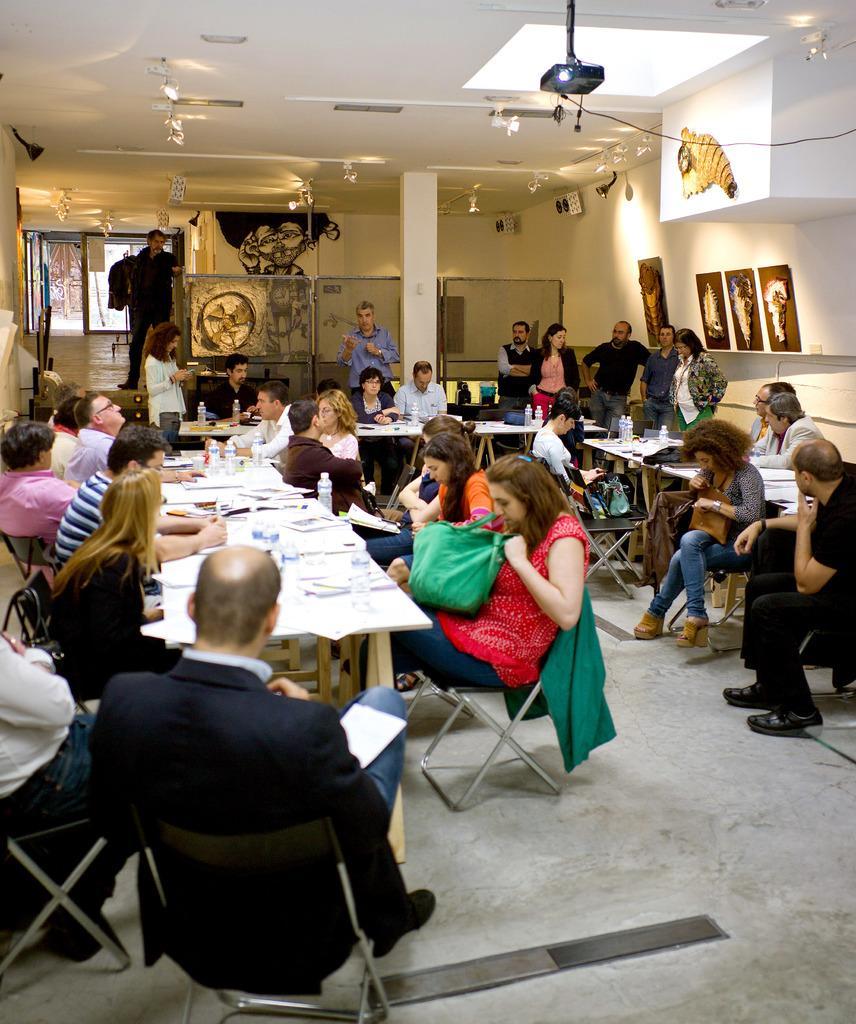How would you summarize this image in a sentence or two? This is the picture of a room. In this image there are group of people sitting in the chairs. At the back there are group of people standing. There are bottles, papers on the table. At the back there is a door and there is a painting on the wall and there are frames on the wall. At the top there are lights and there is a projector. 